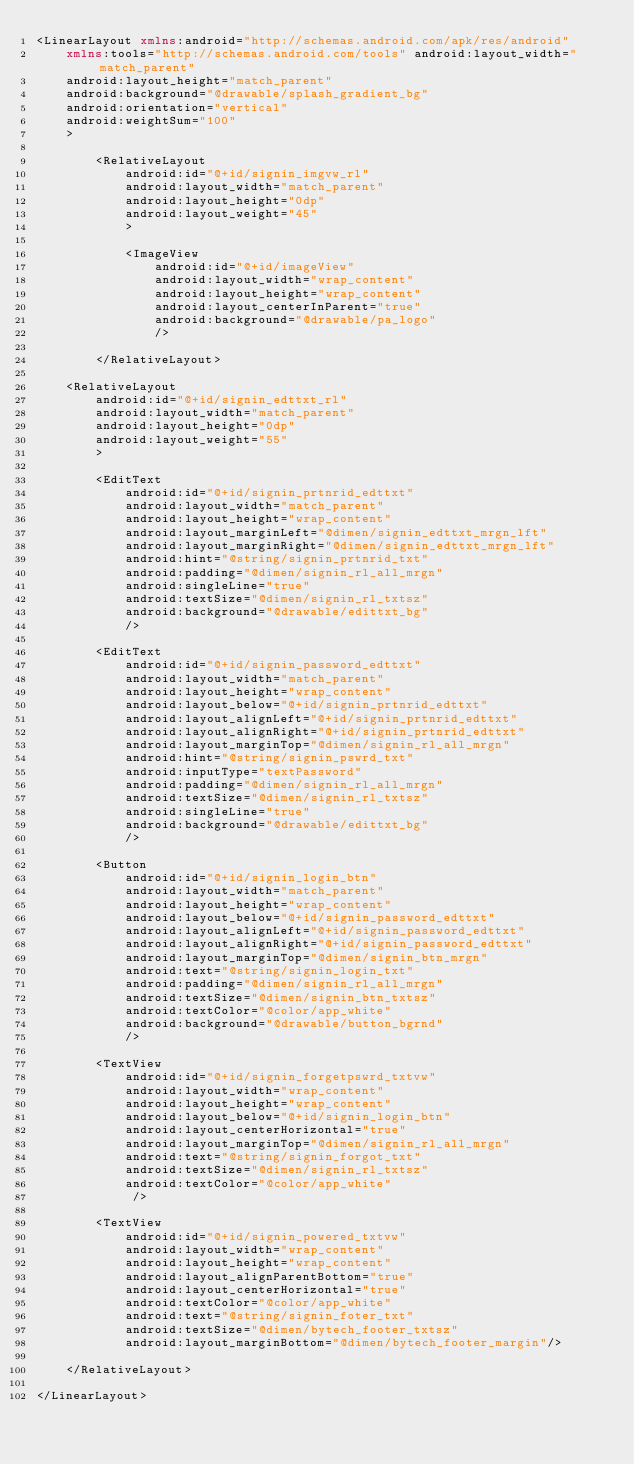<code> <loc_0><loc_0><loc_500><loc_500><_XML_><LinearLayout xmlns:android="http://schemas.android.com/apk/res/android"
    xmlns:tools="http://schemas.android.com/tools" android:layout_width="match_parent"
    android:layout_height="match_parent"
    android:background="@drawable/splash_gradient_bg"
    android:orientation="vertical"
    android:weightSum="100"
    >

        <RelativeLayout
            android:id="@+id/signin_imgvw_rl"
            android:layout_width="match_parent"
            android:layout_height="0dp"
            android:layout_weight="45"
            >

            <ImageView
                android:id="@+id/imageView"
                android:layout_width="wrap_content"
                android:layout_height="wrap_content"
                android:layout_centerInParent="true"
                android:background="@drawable/pa_logo"
                />

        </RelativeLayout>

    <RelativeLayout
        android:id="@+id/signin_edttxt_rl"
        android:layout_width="match_parent"
        android:layout_height="0dp"
        android:layout_weight="55"
        >

        <EditText
            android:id="@+id/signin_prtnrid_edttxt"
            android:layout_width="match_parent"
            android:layout_height="wrap_content"
            android:layout_marginLeft="@dimen/signin_edttxt_mrgn_lft"
            android:layout_marginRight="@dimen/signin_edttxt_mrgn_lft"
            android:hint="@string/signin_prtnrid_txt"
            android:padding="@dimen/signin_rl_all_mrgn"
            android:singleLine="true"
            android:textSize="@dimen/signin_rl_txtsz"
            android:background="@drawable/edittxt_bg"
            />

        <EditText
            android:id="@+id/signin_password_edttxt"
            android:layout_width="match_parent"
            android:layout_height="wrap_content"
            android:layout_below="@+id/signin_prtnrid_edttxt"
            android:layout_alignLeft="@+id/signin_prtnrid_edttxt"
            android:layout_alignRight="@+id/signin_prtnrid_edttxt"
            android:layout_marginTop="@dimen/signin_rl_all_mrgn"
            android:hint="@string/signin_pswrd_txt"
            android:inputType="textPassword"
            android:padding="@dimen/signin_rl_all_mrgn"
            android:textSize="@dimen/signin_rl_txtsz"
            android:singleLine="true"
            android:background="@drawable/edittxt_bg"
            />

        <Button
            android:id="@+id/signin_login_btn"
            android:layout_width="match_parent"
            android:layout_height="wrap_content"
            android:layout_below="@+id/signin_password_edttxt"
            android:layout_alignLeft="@+id/signin_password_edttxt"
            android:layout_alignRight="@+id/signin_password_edttxt"
            android:layout_marginTop="@dimen/signin_btn_mrgn"
            android:text="@string/signin_login_txt"
            android:padding="@dimen/signin_rl_all_mrgn"
            android:textSize="@dimen/signin_btn_txtsz"
            android:textColor="@color/app_white"
            android:background="@drawable/button_bgrnd"
            />

        <TextView
            android:id="@+id/signin_forgetpswrd_txtvw"
            android:layout_width="wrap_content"
            android:layout_height="wrap_content"
            android:layout_below="@+id/signin_login_btn"
            android:layout_centerHorizontal="true"
            android:layout_marginTop="@dimen/signin_rl_all_mrgn"
            android:text="@string/signin_forgot_txt"
            android:textSize="@dimen/signin_rl_txtsz"
            android:textColor="@color/app_white"
             />

        <TextView
            android:id="@+id/signin_powered_txtvw"
            android:layout_width="wrap_content"
            android:layout_height="wrap_content"
            android:layout_alignParentBottom="true"
            android:layout_centerHorizontal="true"
            android:textColor="@color/app_white"
            android:text="@string/signin_foter_txt"
            android:textSize="@dimen/bytech_footer_txtsz"
            android:layout_marginBottom="@dimen/bytech_footer_margin"/>

    </RelativeLayout>

</LinearLayout></code> 